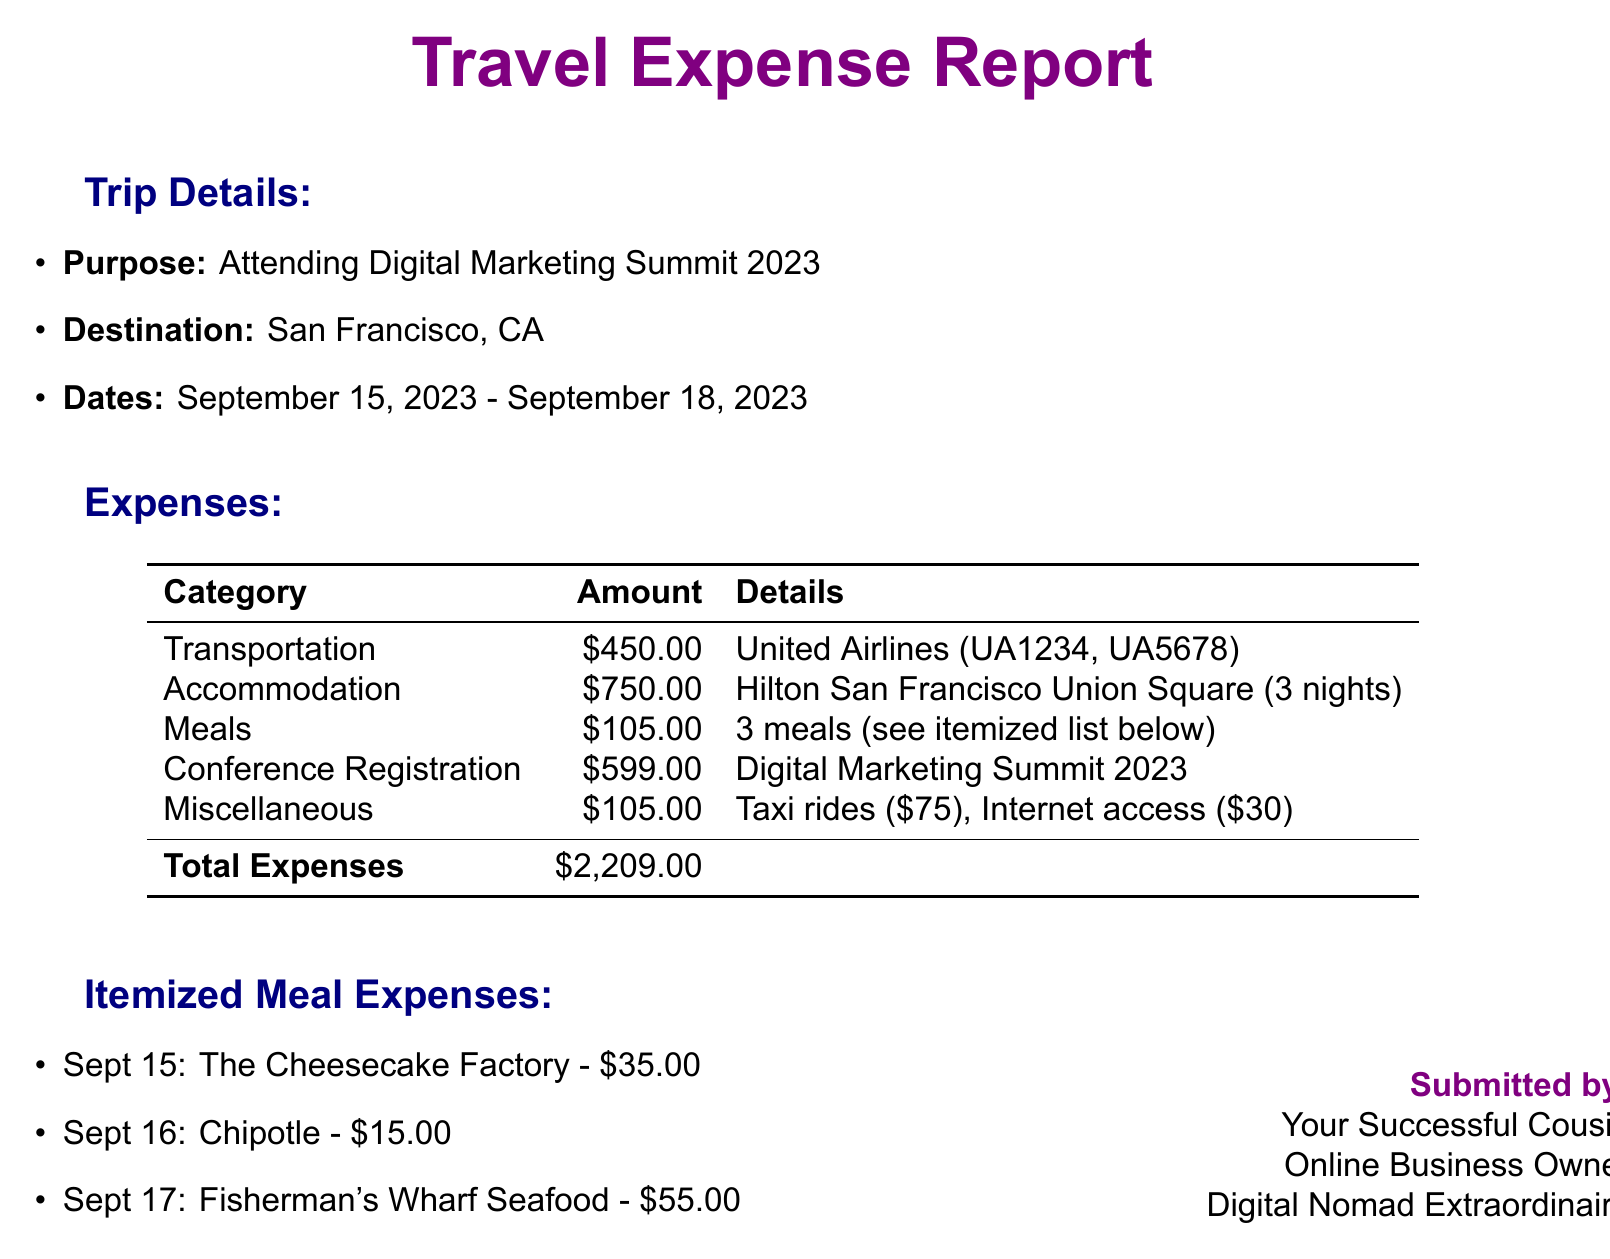What is the destination of the trip? The destination is specified under the Trip Details section in the document.
Answer: San Francisco, CA What is the total expense for the trip? The total expense is the sum of all the individual expenses listed in the document.
Answer: $2,209.00 How many nights was the accommodation booked for? The number of nights is detailed under the Accommodation section in the document.
Answer: 3 nights What was the flight expense? The transportation expense, specifically for flight tickets, is listed in the document.
Answer: $450.00 What was the cost of the conference registration? The conference registration fee is specifically mentioned in the Expenses section.
Answer: $599.00 How much was spent on meals? The meal expense is explicitly stated in the document under the Expenses category.
Answer: $105.00 What is the purpose of the trip? The purpose of the trip is clearly outlined in the Trip Details section.
Answer: Attending Digital Marketing Summit 2023 What is the itemized meal expense for Sept 17? The meal expense for Sept 17 is provided in the Itemized Meal Expenses section.
Answer: $55.00 What is included in miscellaneous expenses? The miscellaneous expenses are listed with specifics in the Expenses section of the document.
Answer: Taxi rides, Internet access 